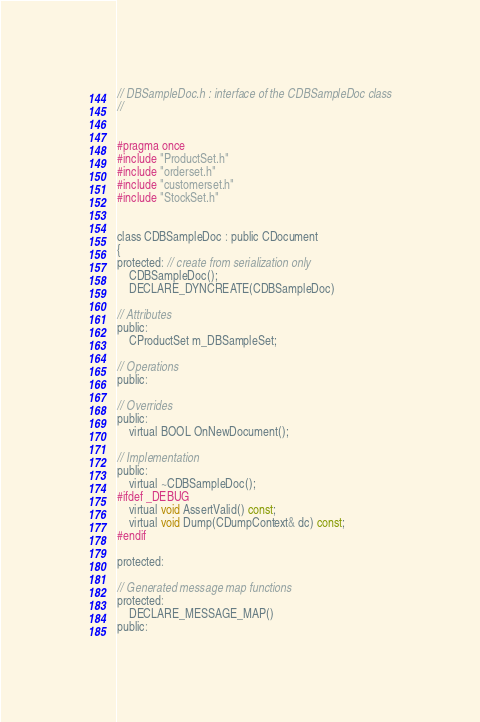Convert code to text. <code><loc_0><loc_0><loc_500><loc_500><_C_>// DBSampleDoc.h : interface of the CDBSampleDoc class
//


#pragma once
#include "ProductSet.h"
#include "orderset.h"
#include "customerset.h"
#include "StockSet.h"


class CDBSampleDoc : public CDocument
{
protected: // create from serialization only
	CDBSampleDoc();
	DECLARE_DYNCREATE(CDBSampleDoc)

// Attributes
public:
	CProductSet m_DBSampleSet;

// Operations
public:

// Overrides
public:
	virtual BOOL OnNewDocument();

// Implementation
public:
	virtual ~CDBSampleDoc();
#ifdef _DEBUG
	virtual void AssertValid() const;
	virtual void Dump(CDumpContext& dc) const;
#endif

protected:

// Generated message map functions
protected:
	DECLARE_MESSAGE_MAP()
public:</code> 